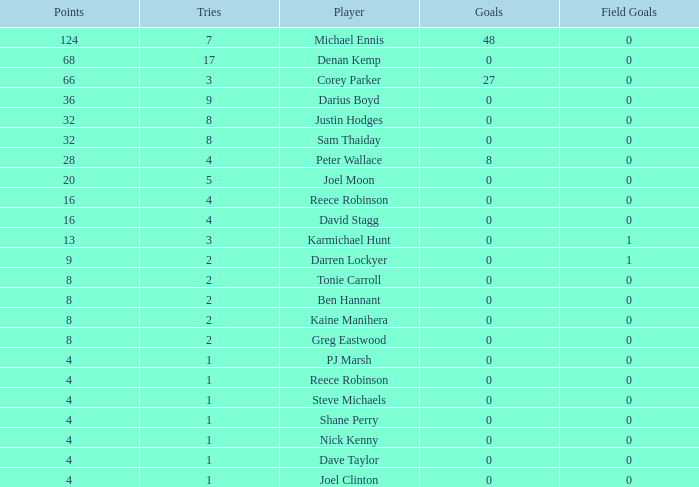How many goals did the player with less than 4 points have? 0.0. 